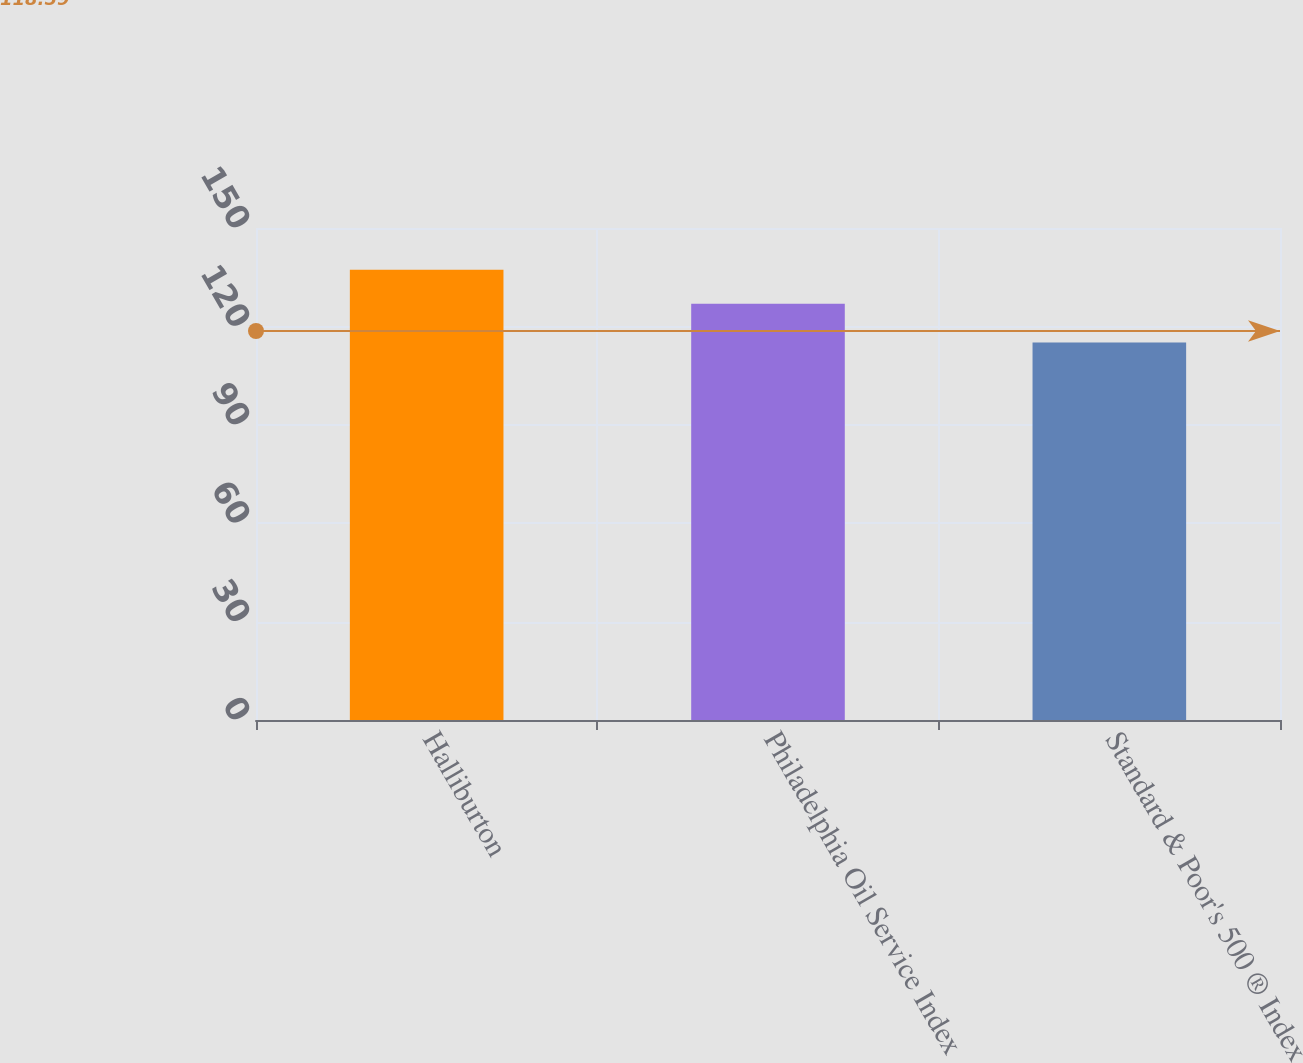Convert chart. <chart><loc_0><loc_0><loc_500><loc_500><bar_chart><fcel>Halliburton<fcel>Philadelphia Oil Service Index<fcel>Standard & Poor's 500 ® Index<nl><fcel>137.25<fcel>126.92<fcel>115.06<nl></chart> 